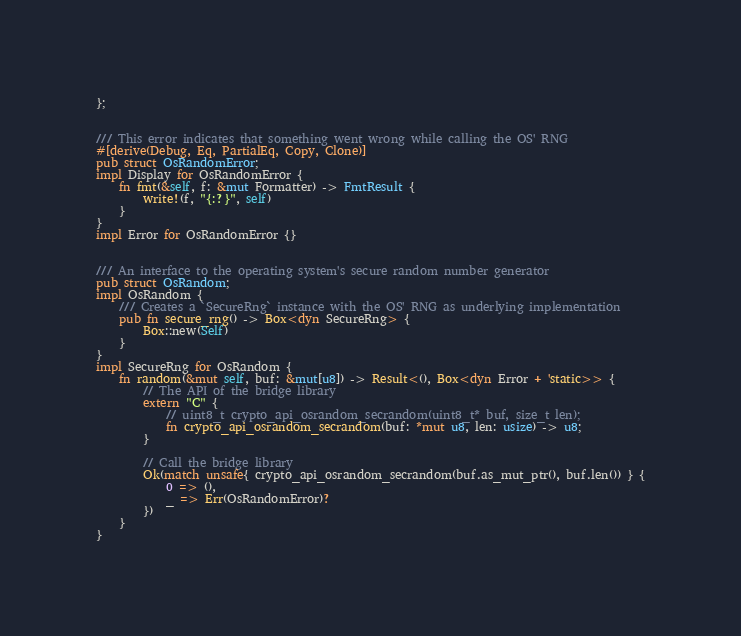<code> <loc_0><loc_0><loc_500><loc_500><_Rust_>};


/// This error indicates that something went wrong while calling the OS' RNG
#[derive(Debug, Eq, PartialEq, Copy, Clone)]
pub struct OsRandomError;
impl Display for OsRandomError {
	fn fmt(&self, f: &mut Formatter) -> FmtResult {
		write!(f, "{:?}", self)
	}
}
impl Error for OsRandomError {}


/// An interface to the operating system's secure random number generator
pub struct OsRandom;
impl OsRandom {
	/// Creates a `SecureRng` instance with the OS' RNG as underlying implementation
	pub fn secure_rng() -> Box<dyn SecureRng> {
		Box::new(Self)
	}
}
impl SecureRng for OsRandom {
	fn random(&mut self, buf: &mut[u8]) -> Result<(), Box<dyn Error + 'static>> {
		// The API of the bridge library
		extern "C" {
			// uint8_t crypto_api_osrandom_secrandom(uint8_t* buf, size_t len);
			fn crypto_api_osrandom_secrandom(buf: *mut u8, len: usize) -> u8;
		}
		
		// Call the bridge library
		Ok(match unsafe{ crypto_api_osrandom_secrandom(buf.as_mut_ptr(), buf.len()) } {
			0 => (),
			_ => Err(OsRandomError)?
		})
	}
}</code> 